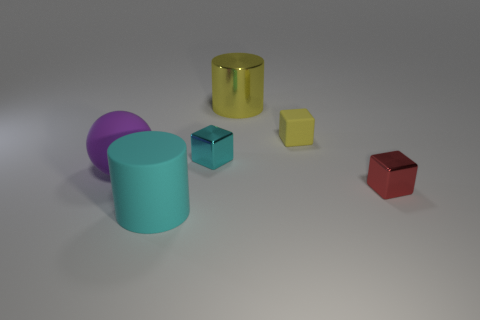How many objects are either large blue rubber cylinders or tiny yellow things?
Offer a terse response. 1. Are there any other things that have the same material as the large purple thing?
Make the answer very short. Yes. Are there fewer rubber cylinders that are in front of the purple object than small cyan objects?
Your response must be concise. No. Is the number of purple matte objects behind the large purple ball greater than the number of yellow cubes that are on the left side of the red block?
Your answer should be very brief. No. Is there any other thing of the same color as the large sphere?
Your answer should be compact. No. There is a big cylinder that is in front of the cyan metal cube; what is it made of?
Your response must be concise. Rubber. Does the cyan rubber cylinder have the same size as the purple rubber ball?
Offer a very short reply. Yes. What number of other objects are the same size as the metal cylinder?
Keep it short and to the point. 2. Do the large sphere and the rubber cylinder have the same color?
Offer a terse response. No. The metal object that is in front of the cyan object behind the cylinder that is in front of the large yellow cylinder is what shape?
Your response must be concise. Cube. 